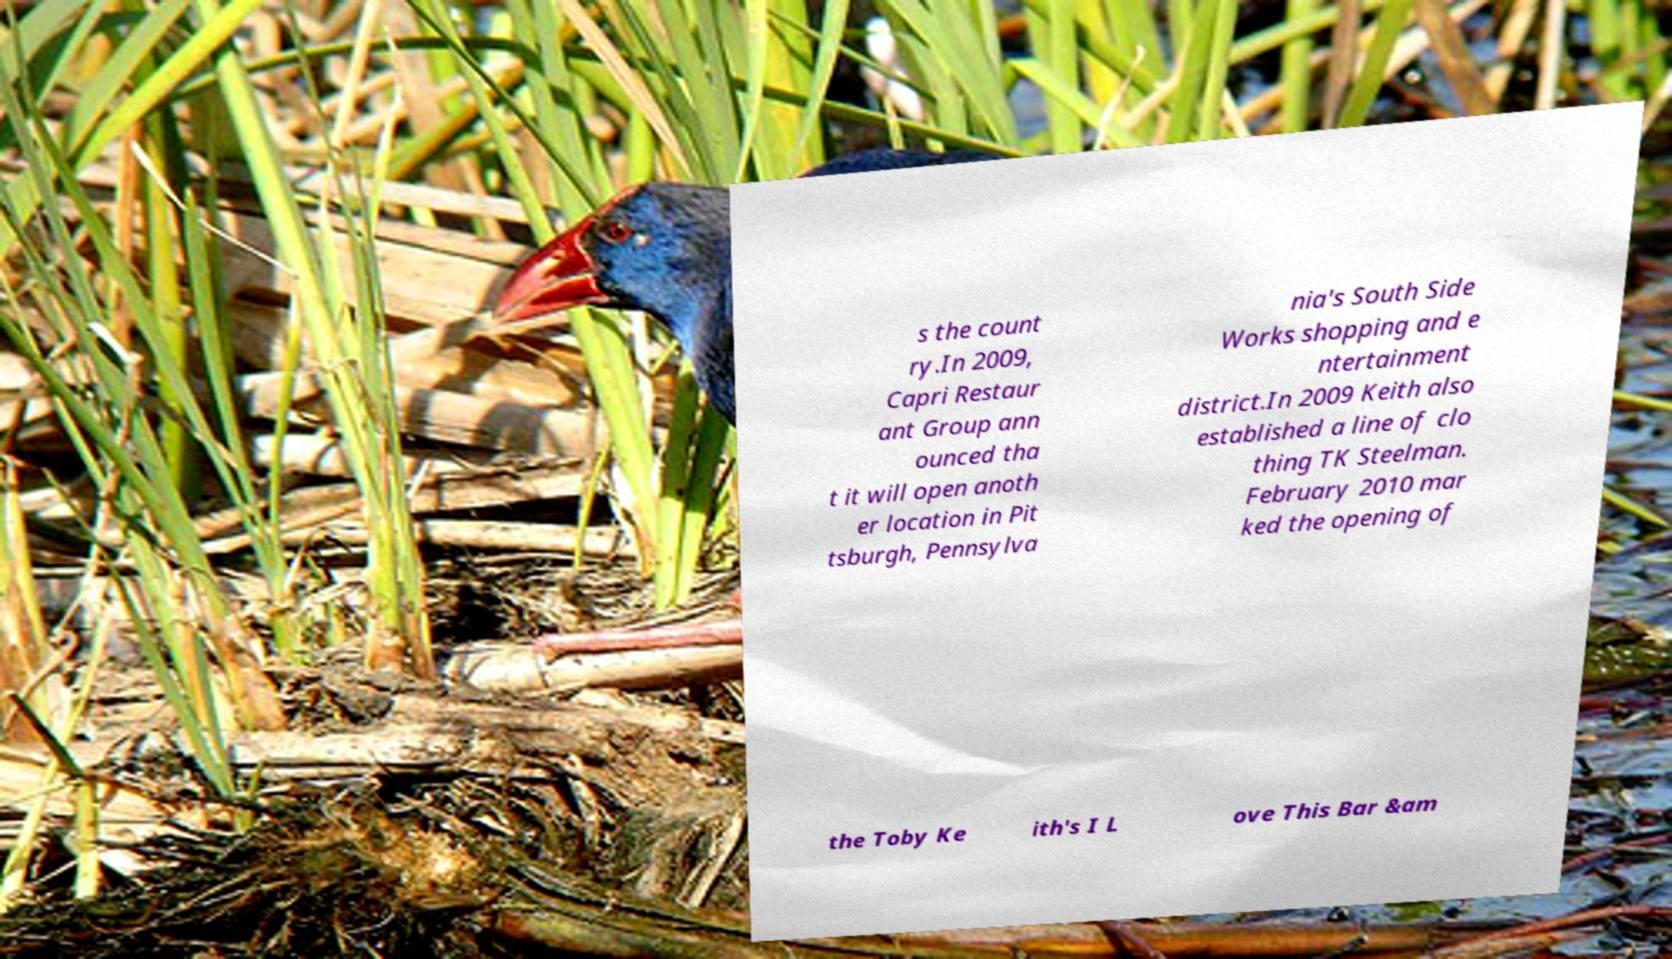Can you read and provide the text displayed in the image?This photo seems to have some interesting text. Can you extract and type it out for me? s the count ry.In 2009, Capri Restaur ant Group ann ounced tha t it will open anoth er location in Pit tsburgh, Pennsylva nia's South Side Works shopping and e ntertainment district.In 2009 Keith also established a line of clo thing TK Steelman. February 2010 mar ked the opening of the Toby Ke ith's I L ove This Bar &am 